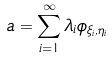<formula> <loc_0><loc_0><loc_500><loc_500>a = \sum _ { i = 1 } ^ { \infty } \lambda _ { i } \phi _ { \xi _ { i } , \eta _ { i } }</formula> 